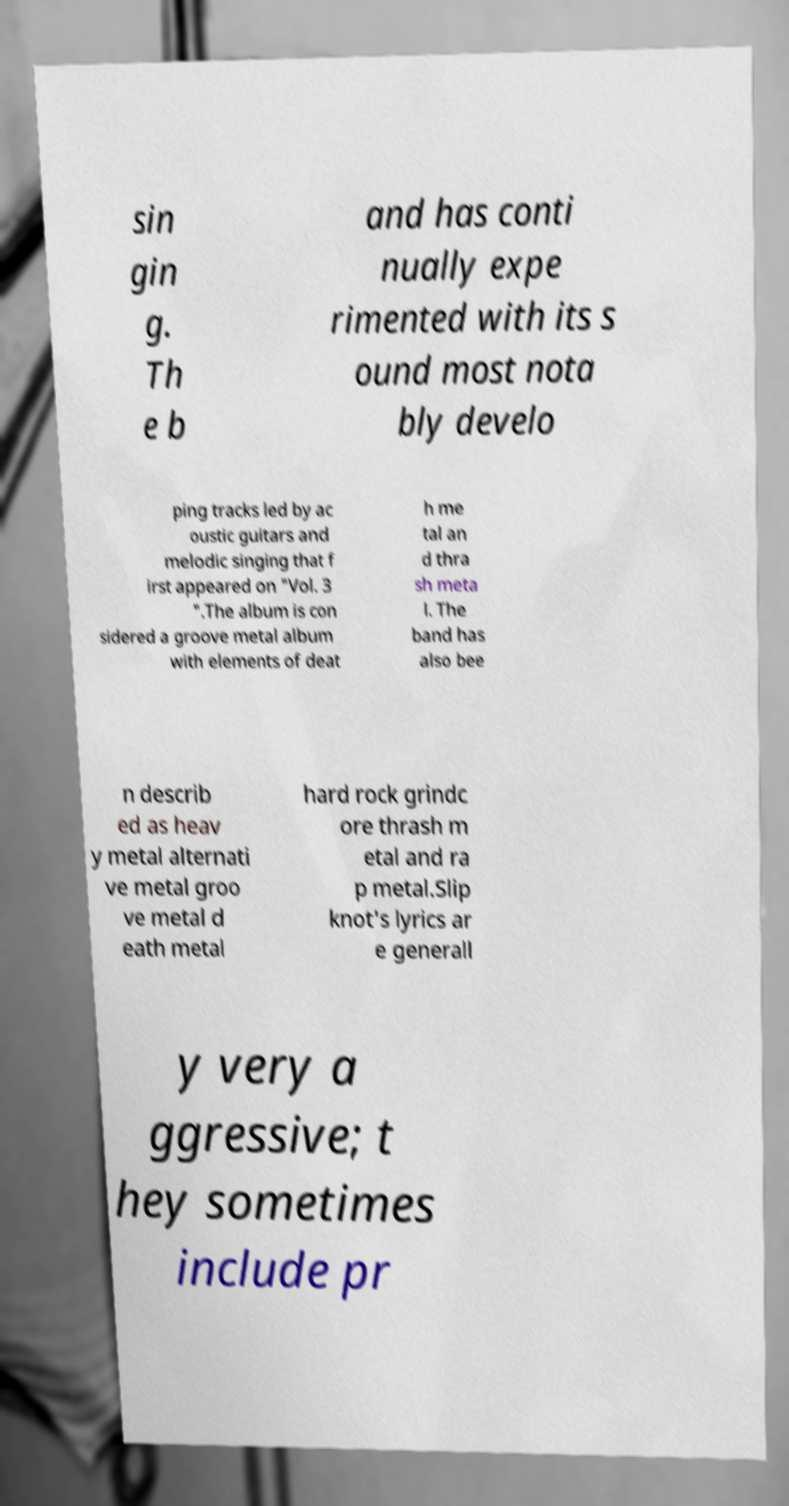For documentation purposes, I need the text within this image transcribed. Could you provide that? sin gin g. Th e b and has conti nually expe rimented with its s ound most nota bly develo ping tracks led by ac oustic guitars and melodic singing that f irst appeared on "Vol. 3 ".The album is con sidered a groove metal album with elements of deat h me tal an d thra sh meta l. The band has also bee n describ ed as heav y metal alternati ve metal groo ve metal d eath metal hard rock grindc ore thrash m etal and ra p metal.Slip knot's lyrics ar e generall y very a ggressive; t hey sometimes include pr 